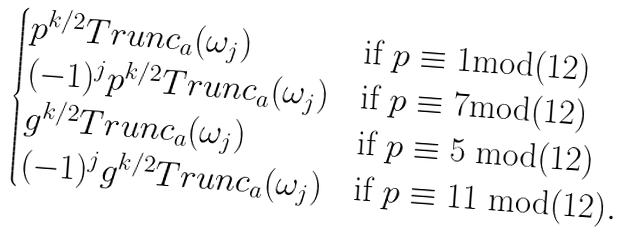<formula> <loc_0><loc_0><loc_500><loc_500>\begin{cases} p ^ { k / 2 } T r u n c _ { a } ( \omega _ { j } ) & \text {if } p \equiv 1 \text {mod(12)} \\ ( - 1 ) ^ { j } p ^ { k / 2 } T r u n c _ { a } ( \omega _ { j } ) & \text {if } p \equiv 7 \text {mod(12)} \\ g ^ { k / 2 } T r u n c _ { a } ( \omega _ { j } ) & \text {if } p \equiv 5 \text { mod(12)} \\ ( - 1 ) ^ { j } g ^ { k / 2 } T r u n c _ { a } ( \omega _ { j } ) & \text {if } p \equiv 1 1 \text { mod(12)} . \end{cases}</formula> 